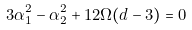<formula> <loc_0><loc_0><loc_500><loc_500>3 \alpha _ { 1 } ^ { 2 } - \alpha _ { 2 } ^ { 2 } + 1 2 \Omega ( d - 3 ) = 0</formula> 